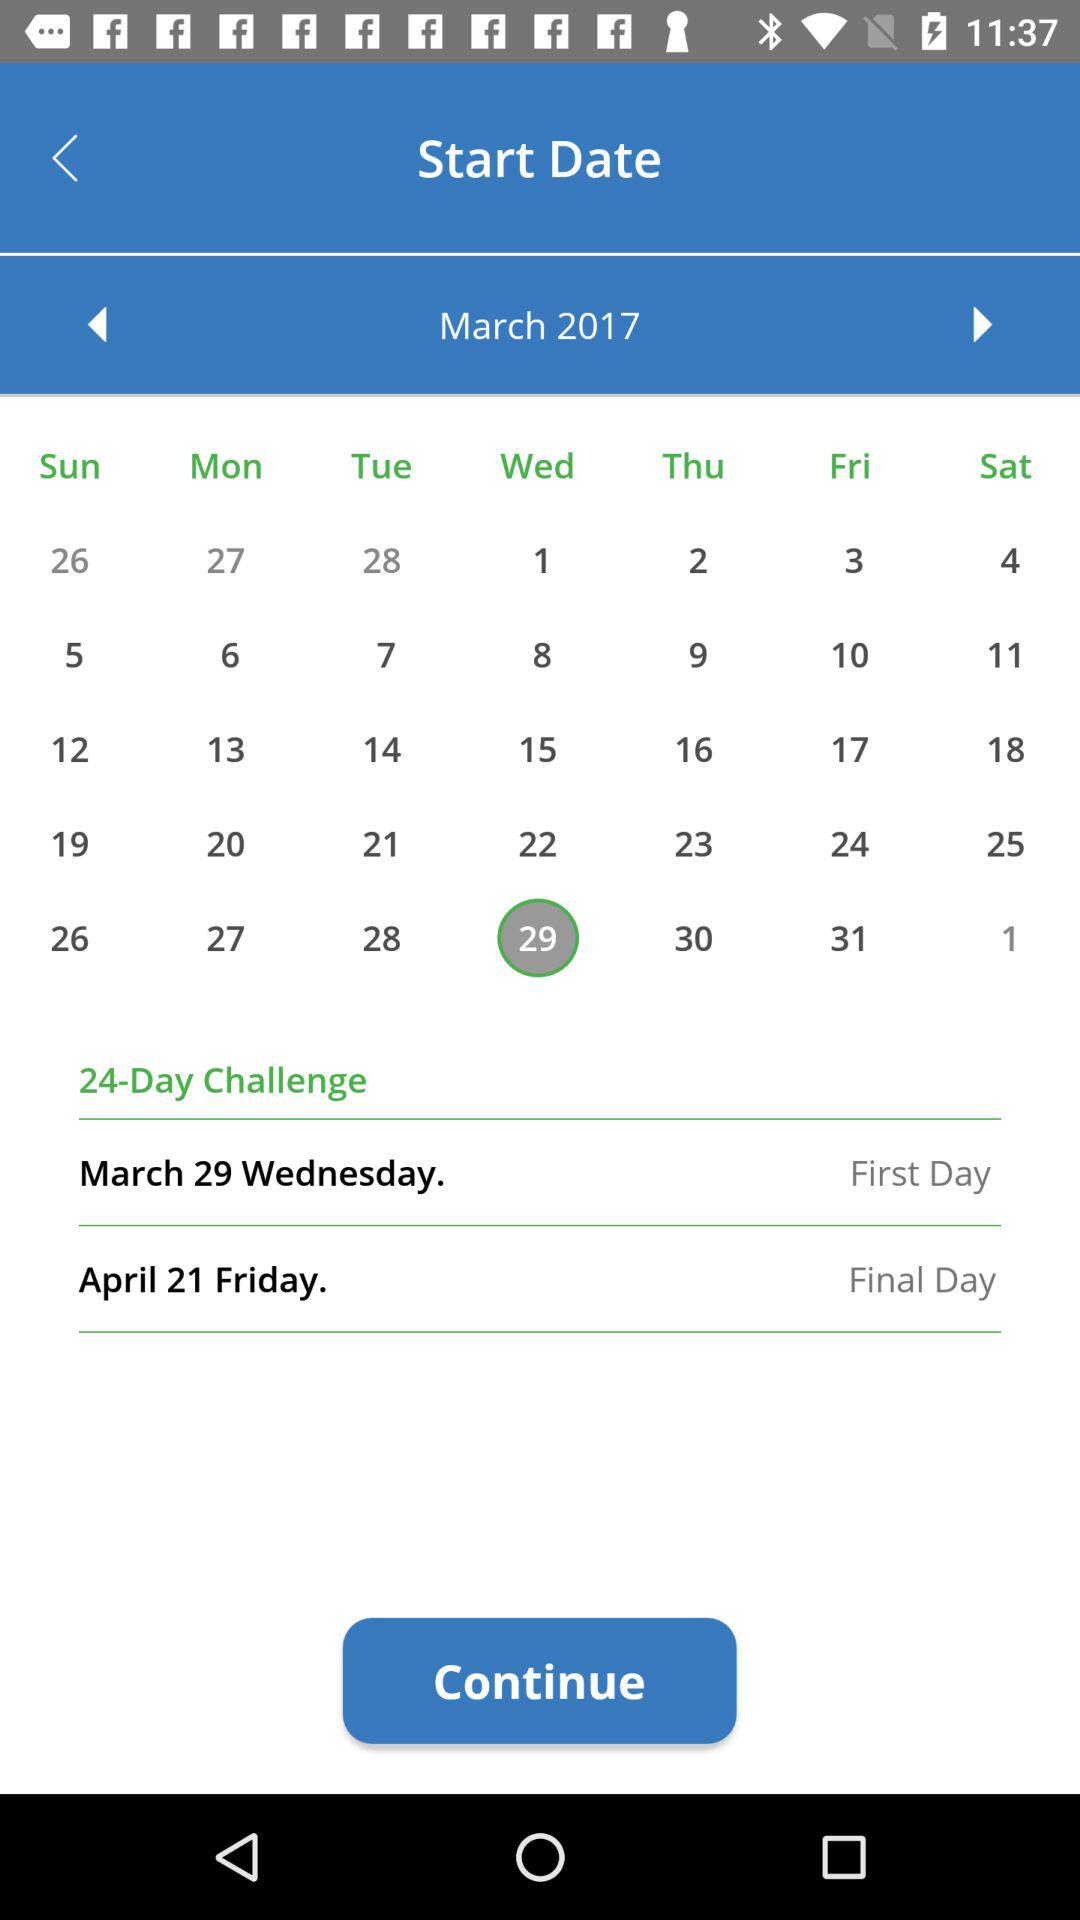What is the number of challenging days? The number of challenging days is 24. 